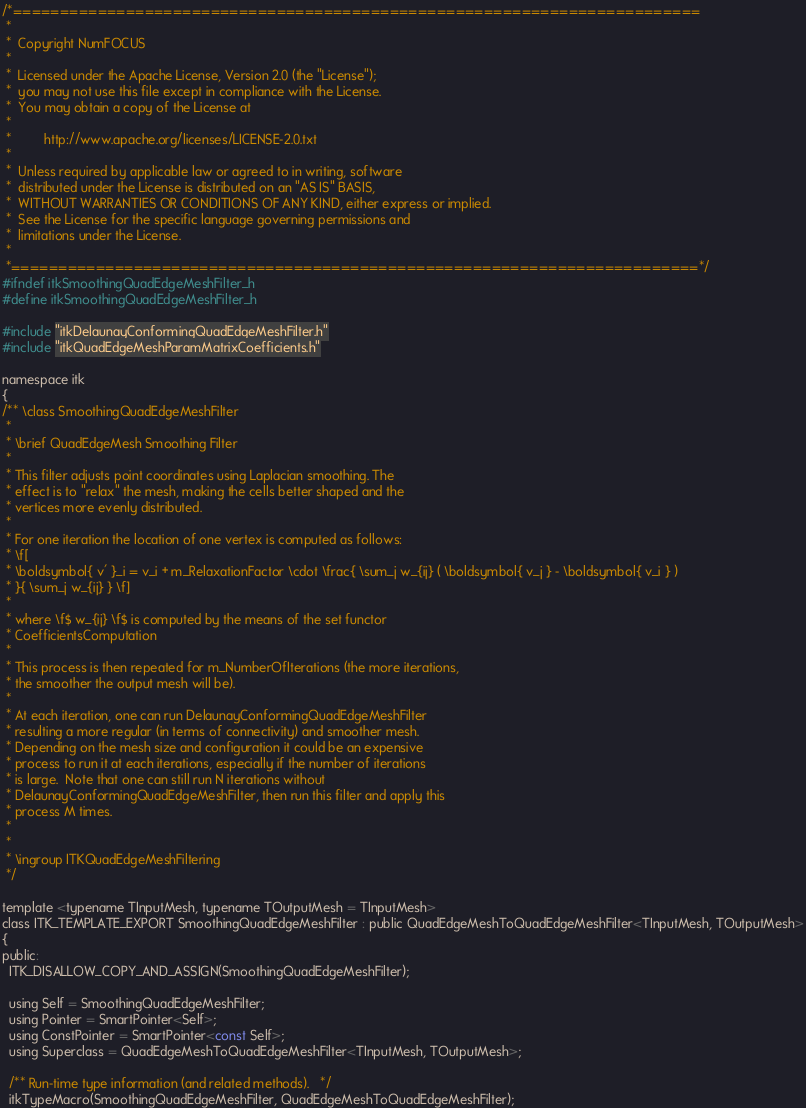Convert code to text. <code><loc_0><loc_0><loc_500><loc_500><_C_>/*=========================================================================
 *
 *  Copyright NumFOCUS
 *
 *  Licensed under the Apache License, Version 2.0 (the "License");
 *  you may not use this file except in compliance with the License.
 *  You may obtain a copy of the License at
 *
 *         http://www.apache.org/licenses/LICENSE-2.0.txt
 *
 *  Unless required by applicable law or agreed to in writing, software
 *  distributed under the License is distributed on an "AS IS" BASIS,
 *  WITHOUT WARRANTIES OR CONDITIONS OF ANY KIND, either express or implied.
 *  See the License for the specific language governing permissions and
 *  limitations under the License.
 *
 *=========================================================================*/
#ifndef itkSmoothingQuadEdgeMeshFilter_h
#define itkSmoothingQuadEdgeMeshFilter_h

#include "itkDelaunayConformingQuadEdgeMeshFilter.h"
#include "itkQuadEdgeMeshParamMatrixCoefficients.h"

namespace itk
{
/** \class SmoothingQuadEdgeMeshFilter
 *
 * \brief QuadEdgeMesh Smoothing Filter
 *
 * This filter adjusts point coordinates using Laplacian smoothing. The
 * effect is to "relax" the mesh, making the cells better shaped and the
 * vertices more evenly distributed.
 *
 * For one iteration the location of one vertex is computed as follows:
 * \f[
 * \boldsymbol{ v' }_i = v_i + m_RelaxationFactor \cdot \frac{ \sum_j w_{ij} ( \boldsymbol{ v_j } - \boldsymbol{ v_i } )
 * }{ \sum_j w_{ij} } \f]
 *
 * where \f$ w_{ij} \f$ is computed by the means of the set functor
 * CoefficientsComputation
 *
 * This process is then repeated for m_NumberOfIterations (the more iterations,
 * the smoother the output mesh will be).
 *
 * At each iteration, one can run DelaunayConformingQuadEdgeMeshFilter
 * resulting a more regular (in terms of connectivity) and smoother mesh.
 * Depending on the mesh size and configuration it could be an expensive
 * process to run it at each iterations, especially if the number of iterations
 * is large.  Note that one can still run N iterations without
 * DelaunayConformingQuadEdgeMeshFilter, then run this filter and apply this
 * process M times.
 *
 *
 * \ingroup ITKQuadEdgeMeshFiltering
 */

template <typename TInputMesh, typename TOutputMesh = TInputMesh>
class ITK_TEMPLATE_EXPORT SmoothingQuadEdgeMeshFilter : public QuadEdgeMeshToQuadEdgeMeshFilter<TInputMesh, TOutputMesh>
{
public:
  ITK_DISALLOW_COPY_AND_ASSIGN(SmoothingQuadEdgeMeshFilter);

  using Self = SmoothingQuadEdgeMeshFilter;
  using Pointer = SmartPointer<Self>;
  using ConstPointer = SmartPointer<const Self>;
  using Superclass = QuadEdgeMeshToQuadEdgeMeshFilter<TInputMesh, TOutputMesh>;

  /** Run-time type information (and related methods).   */
  itkTypeMacro(SmoothingQuadEdgeMeshFilter, QuadEdgeMeshToQuadEdgeMeshFilter);</code> 